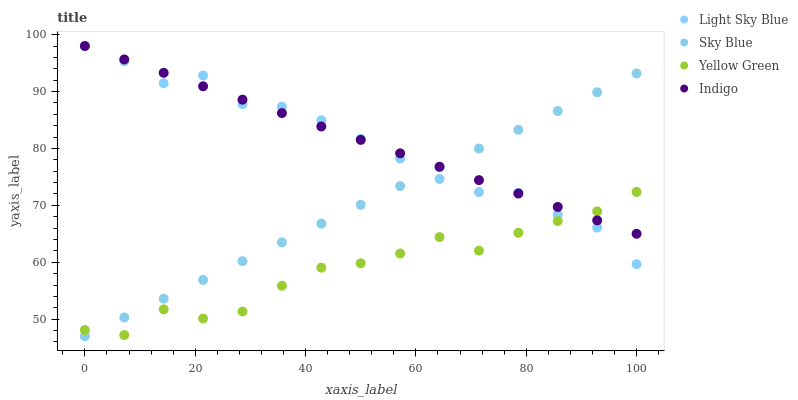Does Yellow Green have the minimum area under the curve?
Answer yes or no. Yes. Does Indigo have the maximum area under the curve?
Answer yes or no. Yes. Does Light Sky Blue have the minimum area under the curve?
Answer yes or no. No. Does Light Sky Blue have the maximum area under the curve?
Answer yes or no. No. Is Indigo the smoothest?
Answer yes or no. Yes. Is Yellow Green the roughest?
Answer yes or no. Yes. Is Light Sky Blue the smoothest?
Answer yes or no. No. Is Light Sky Blue the roughest?
Answer yes or no. No. Does Sky Blue have the lowest value?
Answer yes or no. Yes. Does Light Sky Blue have the lowest value?
Answer yes or no. No. Does Indigo have the highest value?
Answer yes or no. Yes. Does Yellow Green have the highest value?
Answer yes or no. No. Does Yellow Green intersect Indigo?
Answer yes or no. Yes. Is Yellow Green less than Indigo?
Answer yes or no. No. Is Yellow Green greater than Indigo?
Answer yes or no. No. 